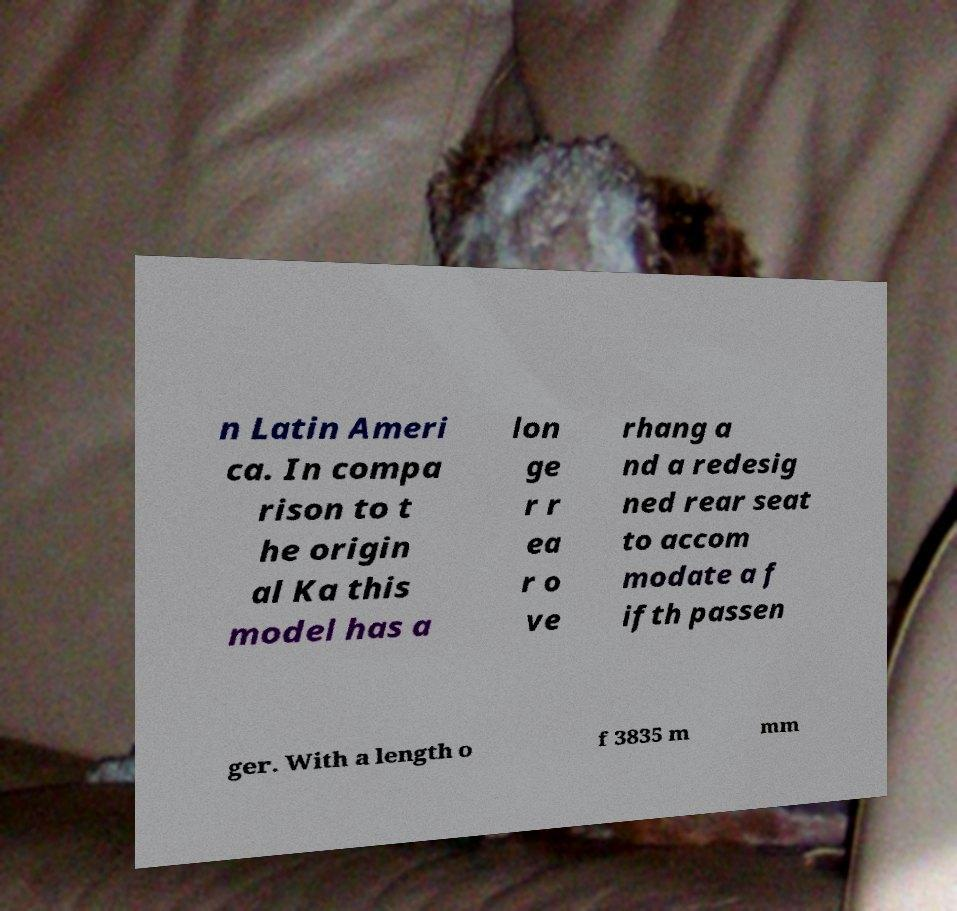Can you read and provide the text displayed in the image?This photo seems to have some interesting text. Can you extract and type it out for me? n Latin Ameri ca. In compa rison to t he origin al Ka this model has a lon ge r r ea r o ve rhang a nd a redesig ned rear seat to accom modate a f ifth passen ger. With a length o f 3835 m mm 